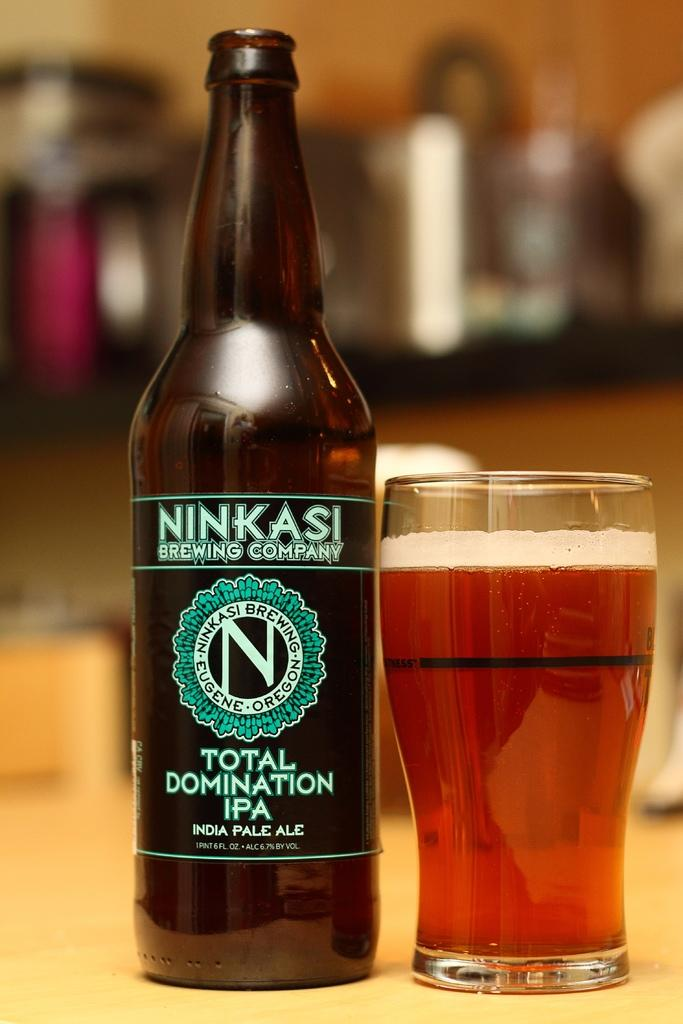Provide a one-sentence caption for the provided image. A beer bottle from the Ninkasi Brewing company and a full glass of amber colored beer. 